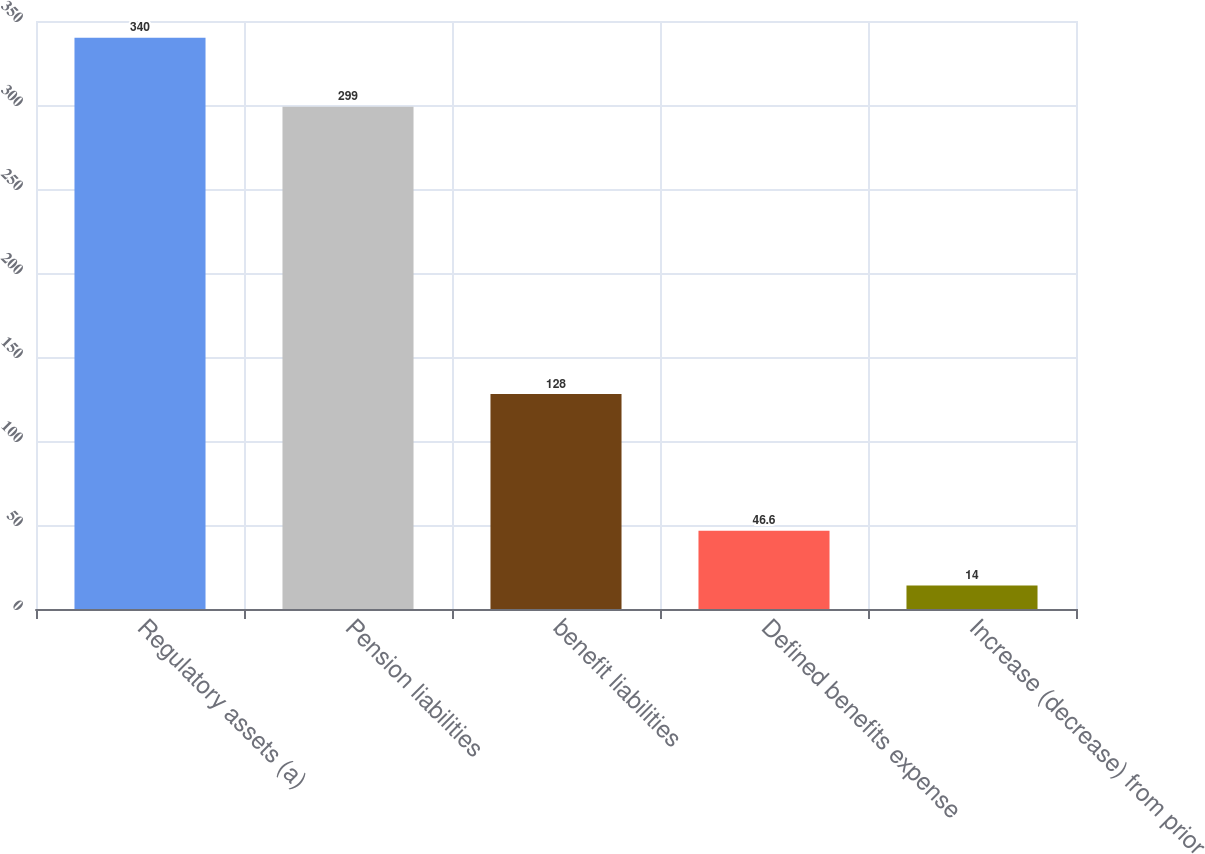<chart> <loc_0><loc_0><loc_500><loc_500><bar_chart><fcel>Regulatory assets (a)<fcel>Pension liabilities<fcel>benefit liabilities<fcel>Defined benefits expense<fcel>Increase (decrease) from prior<nl><fcel>340<fcel>299<fcel>128<fcel>46.6<fcel>14<nl></chart> 